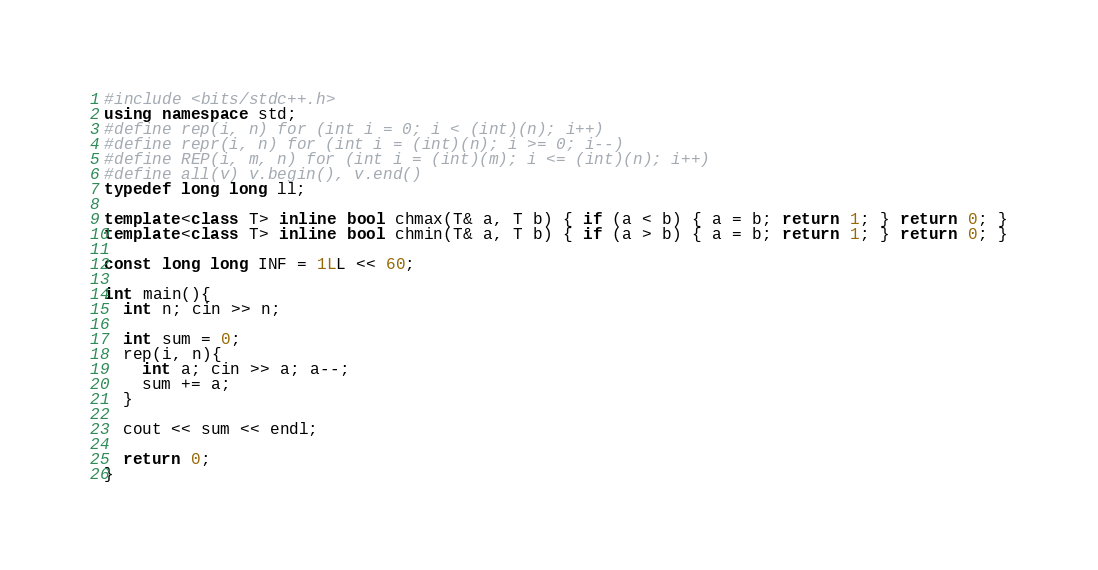<code> <loc_0><loc_0><loc_500><loc_500><_C++_>#include <bits/stdc++.h>
using namespace std;
#define rep(i, n) for (int i = 0; i < (int)(n); i++)
#define repr(i, n) for (int i = (int)(n); i >= 0; i--)
#define REP(i, m, n) for (int i = (int)(m); i <= (int)(n); i++)
#define all(v) v.begin(), v.end()
typedef long long ll;

template<class T> inline bool chmax(T& a, T b) { if (a < b) { a = b; return 1; } return 0; }
template<class T> inline bool chmin(T& a, T b) { if (a > b) { a = b; return 1; } return 0; }

const long long INF = 1LL << 60;

int main(){
  int n; cin >> n;

  int sum = 0;
  rep(i, n){
    int a; cin >> a; a--;
    sum += a;
  }

  cout << sum << endl;

  return 0;
}
</code> 